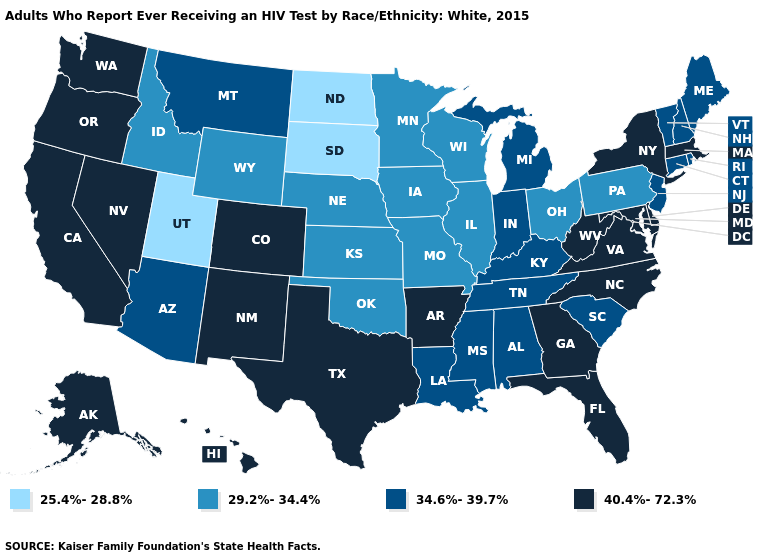What is the highest value in the South ?
Concise answer only. 40.4%-72.3%. Name the states that have a value in the range 25.4%-28.8%?
Give a very brief answer. North Dakota, South Dakota, Utah. Which states hav the highest value in the South?
Keep it brief. Arkansas, Delaware, Florida, Georgia, Maryland, North Carolina, Texas, Virginia, West Virginia. Name the states that have a value in the range 40.4%-72.3%?
Write a very short answer. Alaska, Arkansas, California, Colorado, Delaware, Florida, Georgia, Hawaii, Maryland, Massachusetts, Nevada, New Mexico, New York, North Carolina, Oregon, Texas, Virginia, Washington, West Virginia. Among the states that border New York , does Massachusetts have the lowest value?
Answer briefly. No. What is the lowest value in states that border New Jersey?
Be succinct. 29.2%-34.4%. What is the highest value in states that border California?
Concise answer only. 40.4%-72.3%. Name the states that have a value in the range 34.6%-39.7%?
Keep it brief. Alabama, Arizona, Connecticut, Indiana, Kentucky, Louisiana, Maine, Michigan, Mississippi, Montana, New Hampshire, New Jersey, Rhode Island, South Carolina, Tennessee, Vermont. What is the value of Delaware?
Quick response, please. 40.4%-72.3%. Which states have the lowest value in the USA?
Write a very short answer. North Dakota, South Dakota, Utah. Does Tennessee have a higher value than Wyoming?
Keep it brief. Yes. Which states have the highest value in the USA?
Concise answer only. Alaska, Arkansas, California, Colorado, Delaware, Florida, Georgia, Hawaii, Maryland, Massachusetts, Nevada, New Mexico, New York, North Carolina, Oregon, Texas, Virginia, Washington, West Virginia. Among the states that border Oregon , which have the lowest value?
Short answer required. Idaho. Among the states that border Virginia , which have the lowest value?
Give a very brief answer. Kentucky, Tennessee. What is the value of Massachusetts?
Keep it brief. 40.4%-72.3%. 